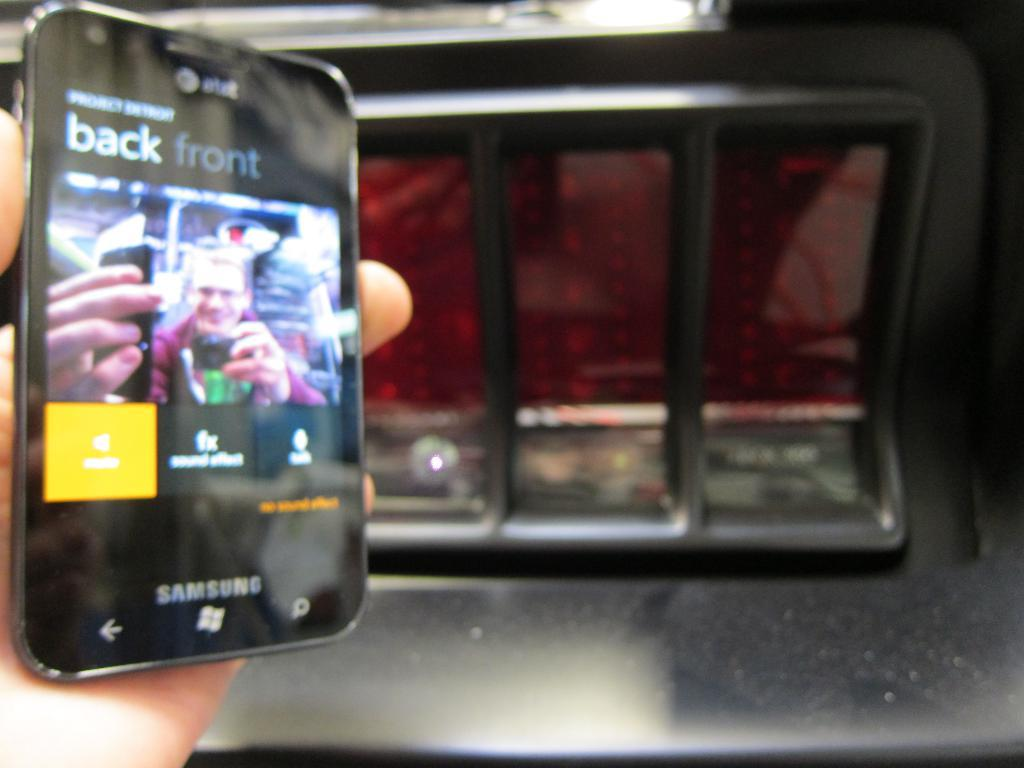<image>
Write a terse but informative summary of the picture. a SAMSUNG tablet with 'back front' on the screen of it. 